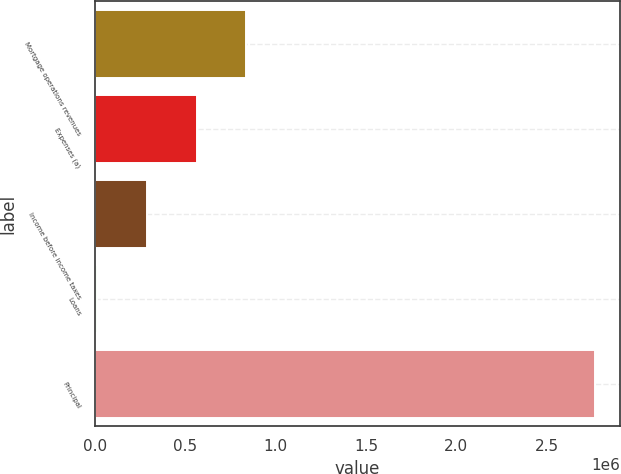Convert chart. <chart><loc_0><loc_0><loc_500><loc_500><bar_chart><fcel>Mortgage operations revenues<fcel>Expenses (a)<fcel>Income before income taxes<fcel>Loans<fcel>Principal<nl><fcel>837925<fcel>562556<fcel>287187<fcel>11818<fcel>2.76551e+06<nl></chart> 